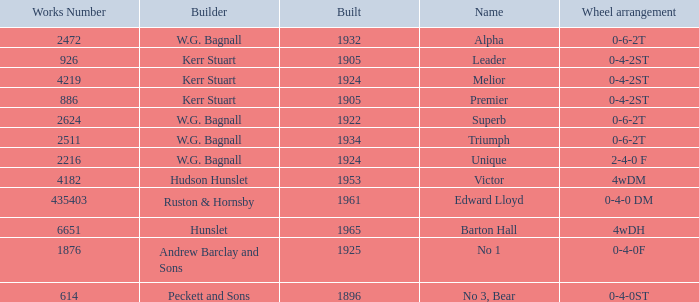What is the average building year for Superb? 1922.0. 